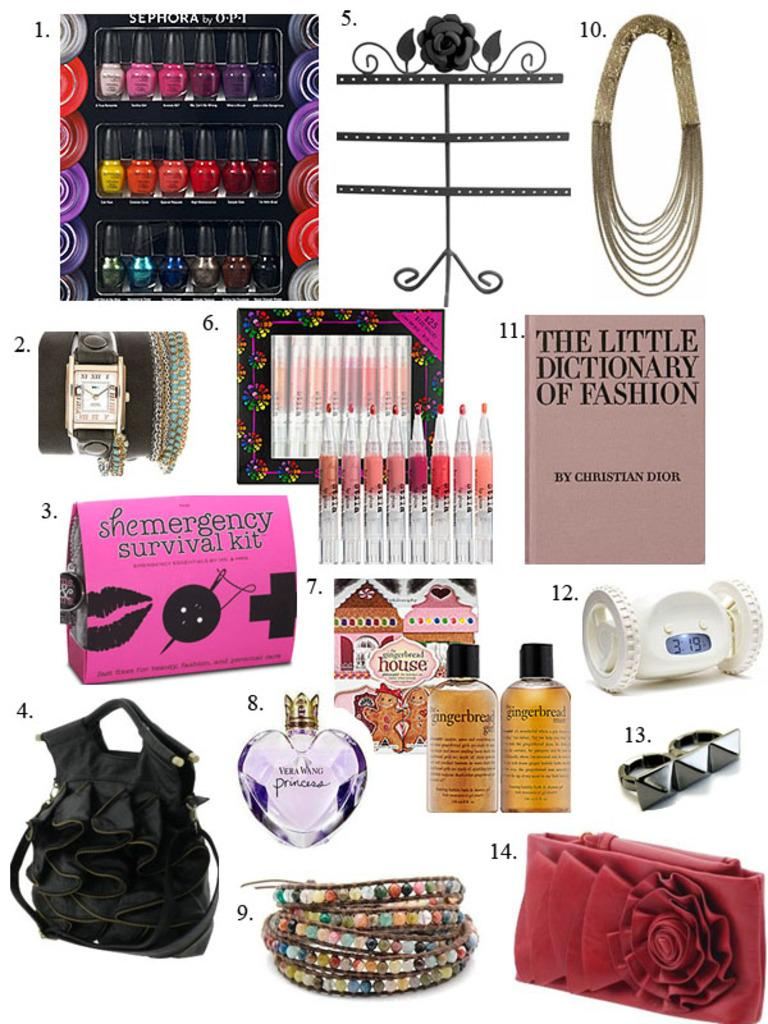<image>
Render a clear and concise summary of the photo. Several different items on a page, one being a book titled The Little Dictionary of Fashion. 